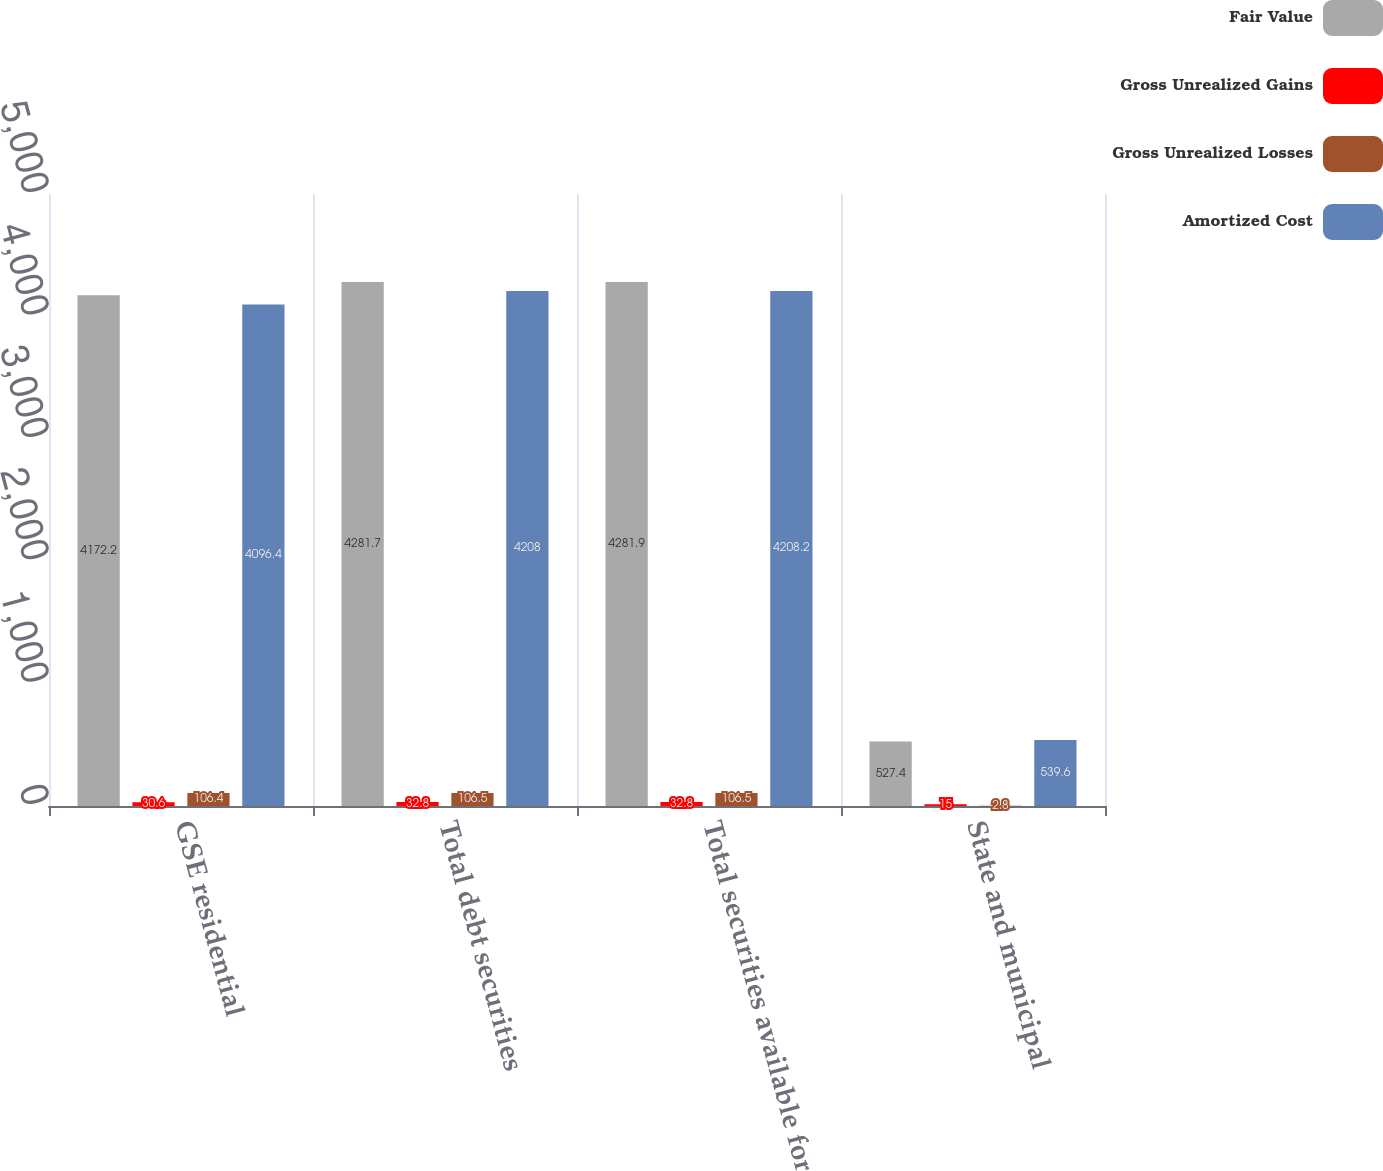<chart> <loc_0><loc_0><loc_500><loc_500><stacked_bar_chart><ecel><fcel>GSE residential<fcel>Total debt securities<fcel>Total securities available for<fcel>State and municipal<nl><fcel>Fair Value<fcel>4172.2<fcel>4281.7<fcel>4281.9<fcel>527.4<nl><fcel>Gross Unrealized Gains<fcel>30.6<fcel>32.8<fcel>32.8<fcel>15<nl><fcel>Gross Unrealized Losses<fcel>106.4<fcel>106.5<fcel>106.5<fcel>2.8<nl><fcel>Amortized Cost<fcel>4096.4<fcel>4208<fcel>4208.2<fcel>539.6<nl></chart> 